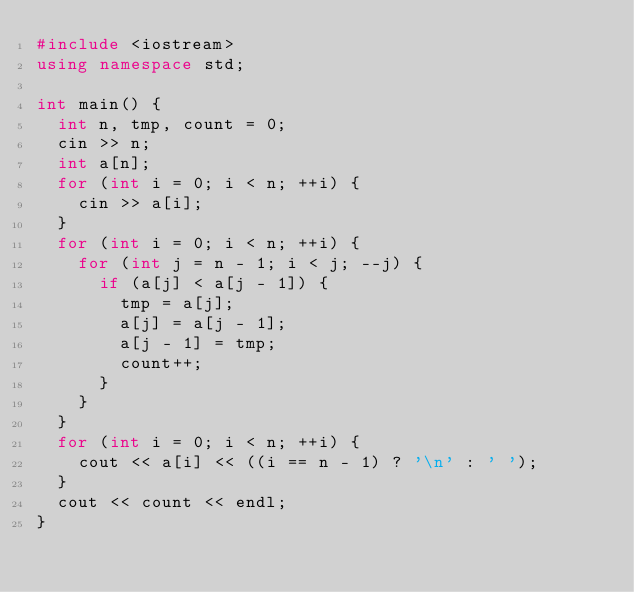Convert code to text. <code><loc_0><loc_0><loc_500><loc_500><_C++_>#include <iostream>
using namespace std;

int main() {
  int n, tmp, count = 0;
  cin >> n;
  int a[n];
  for (int i = 0; i < n; ++i) {
    cin >> a[i];
  }
  for (int i = 0; i < n; ++i) {
    for (int j = n - 1; i < j; --j) {
      if (a[j] < a[j - 1]) {
        tmp = a[j];
        a[j] = a[j - 1];
        a[j - 1] = tmp;
        count++;
      }
    }
  }
  for (int i = 0; i < n; ++i) {
    cout << a[i] << ((i == n - 1) ? '\n' : ' ');
  }
  cout << count << endl;
}

</code> 